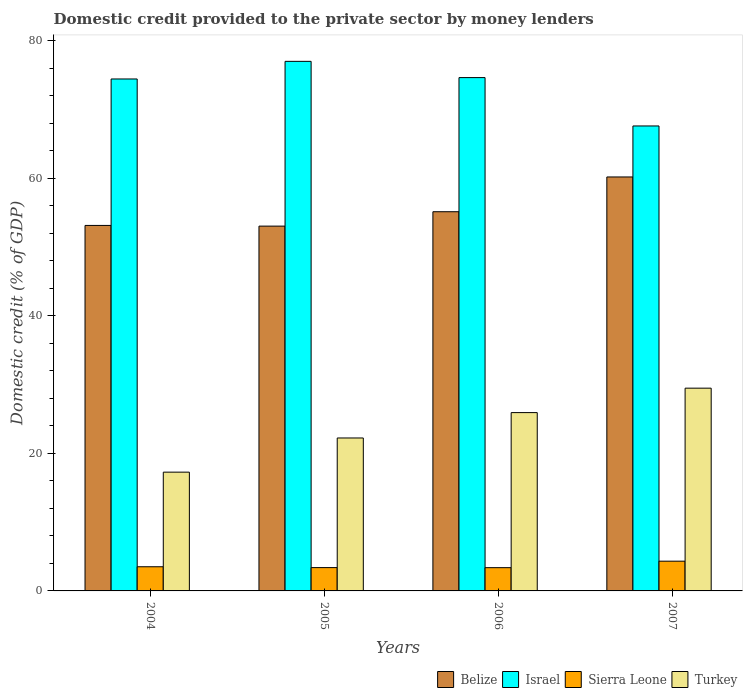How many different coloured bars are there?
Give a very brief answer. 4. Are the number of bars per tick equal to the number of legend labels?
Ensure brevity in your answer.  Yes. Are the number of bars on each tick of the X-axis equal?
Provide a succinct answer. Yes. How many bars are there on the 1st tick from the right?
Offer a very short reply. 4. What is the label of the 4th group of bars from the left?
Your response must be concise. 2007. What is the domestic credit provided to the private sector by money lenders in Belize in 2006?
Offer a terse response. 55.16. Across all years, what is the maximum domestic credit provided to the private sector by money lenders in Turkey?
Provide a succinct answer. 29.5. Across all years, what is the minimum domestic credit provided to the private sector by money lenders in Belize?
Offer a very short reply. 53.07. In which year was the domestic credit provided to the private sector by money lenders in Belize maximum?
Your answer should be very brief. 2007. In which year was the domestic credit provided to the private sector by money lenders in Israel minimum?
Provide a succinct answer. 2007. What is the total domestic credit provided to the private sector by money lenders in Belize in the graph?
Ensure brevity in your answer.  221.62. What is the difference between the domestic credit provided to the private sector by money lenders in Sierra Leone in 2005 and that in 2006?
Provide a succinct answer. 0.01. What is the difference between the domestic credit provided to the private sector by money lenders in Turkey in 2007 and the domestic credit provided to the private sector by money lenders in Israel in 2006?
Provide a short and direct response. -45.18. What is the average domestic credit provided to the private sector by money lenders in Belize per year?
Your response must be concise. 55.41. In the year 2007, what is the difference between the domestic credit provided to the private sector by money lenders in Sierra Leone and domestic credit provided to the private sector by money lenders in Turkey?
Ensure brevity in your answer.  -25.17. What is the ratio of the domestic credit provided to the private sector by money lenders in Turkey in 2004 to that in 2005?
Provide a succinct answer. 0.78. Is the domestic credit provided to the private sector by money lenders in Turkey in 2004 less than that in 2007?
Your answer should be very brief. Yes. What is the difference between the highest and the second highest domestic credit provided to the private sector by money lenders in Belize?
Your answer should be compact. 5.06. What is the difference between the highest and the lowest domestic credit provided to the private sector by money lenders in Sierra Leone?
Ensure brevity in your answer.  0.94. Is the sum of the domestic credit provided to the private sector by money lenders in Turkey in 2005 and 2006 greater than the maximum domestic credit provided to the private sector by money lenders in Sierra Leone across all years?
Offer a terse response. Yes. What does the 3rd bar from the left in 2007 represents?
Offer a very short reply. Sierra Leone. What does the 1st bar from the right in 2004 represents?
Make the answer very short. Turkey. How many bars are there?
Provide a short and direct response. 16. Are all the bars in the graph horizontal?
Your answer should be compact. No. How many years are there in the graph?
Keep it short and to the point. 4. What is the difference between two consecutive major ticks on the Y-axis?
Keep it short and to the point. 20. How many legend labels are there?
Ensure brevity in your answer.  4. How are the legend labels stacked?
Your answer should be very brief. Horizontal. What is the title of the graph?
Give a very brief answer. Domestic credit provided to the private sector by money lenders. Does "Greece" appear as one of the legend labels in the graph?
Provide a short and direct response. No. What is the label or title of the Y-axis?
Offer a very short reply. Domestic credit (% of GDP). What is the Domestic credit (% of GDP) in Belize in 2004?
Make the answer very short. 53.17. What is the Domestic credit (% of GDP) in Israel in 2004?
Your response must be concise. 74.47. What is the Domestic credit (% of GDP) of Sierra Leone in 2004?
Provide a succinct answer. 3.52. What is the Domestic credit (% of GDP) of Turkey in 2004?
Provide a short and direct response. 17.28. What is the Domestic credit (% of GDP) in Belize in 2005?
Keep it short and to the point. 53.07. What is the Domestic credit (% of GDP) in Israel in 2005?
Your answer should be compact. 77.04. What is the Domestic credit (% of GDP) in Sierra Leone in 2005?
Offer a terse response. 3.39. What is the Domestic credit (% of GDP) of Turkey in 2005?
Your answer should be very brief. 22.25. What is the Domestic credit (% of GDP) of Belize in 2006?
Your answer should be very brief. 55.16. What is the Domestic credit (% of GDP) in Israel in 2006?
Give a very brief answer. 74.67. What is the Domestic credit (% of GDP) of Sierra Leone in 2006?
Your answer should be compact. 3.38. What is the Domestic credit (% of GDP) in Turkey in 2006?
Offer a very short reply. 25.94. What is the Domestic credit (% of GDP) of Belize in 2007?
Provide a short and direct response. 60.22. What is the Domestic credit (% of GDP) in Israel in 2007?
Your answer should be very brief. 67.64. What is the Domestic credit (% of GDP) of Sierra Leone in 2007?
Make the answer very short. 4.33. What is the Domestic credit (% of GDP) of Turkey in 2007?
Give a very brief answer. 29.5. Across all years, what is the maximum Domestic credit (% of GDP) of Belize?
Your response must be concise. 60.22. Across all years, what is the maximum Domestic credit (% of GDP) in Israel?
Keep it short and to the point. 77.04. Across all years, what is the maximum Domestic credit (% of GDP) in Sierra Leone?
Give a very brief answer. 4.33. Across all years, what is the maximum Domestic credit (% of GDP) of Turkey?
Your answer should be compact. 29.5. Across all years, what is the minimum Domestic credit (% of GDP) of Belize?
Provide a short and direct response. 53.07. Across all years, what is the minimum Domestic credit (% of GDP) in Israel?
Provide a short and direct response. 67.64. Across all years, what is the minimum Domestic credit (% of GDP) of Sierra Leone?
Ensure brevity in your answer.  3.38. Across all years, what is the minimum Domestic credit (% of GDP) in Turkey?
Keep it short and to the point. 17.28. What is the total Domestic credit (% of GDP) of Belize in the graph?
Offer a very short reply. 221.62. What is the total Domestic credit (% of GDP) of Israel in the graph?
Your answer should be compact. 293.83. What is the total Domestic credit (% of GDP) in Sierra Leone in the graph?
Ensure brevity in your answer.  14.62. What is the total Domestic credit (% of GDP) of Turkey in the graph?
Provide a succinct answer. 94.97. What is the difference between the Domestic credit (% of GDP) of Belize in 2004 and that in 2005?
Offer a very short reply. 0.1. What is the difference between the Domestic credit (% of GDP) in Israel in 2004 and that in 2005?
Make the answer very short. -2.56. What is the difference between the Domestic credit (% of GDP) of Sierra Leone in 2004 and that in 2005?
Ensure brevity in your answer.  0.12. What is the difference between the Domestic credit (% of GDP) in Turkey in 2004 and that in 2005?
Your answer should be compact. -4.97. What is the difference between the Domestic credit (% of GDP) of Belize in 2004 and that in 2006?
Keep it short and to the point. -1.99. What is the difference between the Domestic credit (% of GDP) of Sierra Leone in 2004 and that in 2006?
Your answer should be compact. 0.13. What is the difference between the Domestic credit (% of GDP) of Turkey in 2004 and that in 2006?
Your answer should be compact. -8.66. What is the difference between the Domestic credit (% of GDP) of Belize in 2004 and that in 2007?
Ensure brevity in your answer.  -7.05. What is the difference between the Domestic credit (% of GDP) in Israel in 2004 and that in 2007?
Your answer should be compact. 6.84. What is the difference between the Domestic credit (% of GDP) of Sierra Leone in 2004 and that in 2007?
Give a very brief answer. -0.81. What is the difference between the Domestic credit (% of GDP) in Turkey in 2004 and that in 2007?
Make the answer very short. -12.22. What is the difference between the Domestic credit (% of GDP) of Belize in 2005 and that in 2006?
Provide a succinct answer. -2.09. What is the difference between the Domestic credit (% of GDP) in Israel in 2005 and that in 2006?
Offer a terse response. 2.36. What is the difference between the Domestic credit (% of GDP) of Sierra Leone in 2005 and that in 2006?
Your answer should be compact. 0.01. What is the difference between the Domestic credit (% of GDP) in Turkey in 2005 and that in 2006?
Give a very brief answer. -3.69. What is the difference between the Domestic credit (% of GDP) in Belize in 2005 and that in 2007?
Your response must be concise. -7.15. What is the difference between the Domestic credit (% of GDP) in Israel in 2005 and that in 2007?
Keep it short and to the point. 9.4. What is the difference between the Domestic credit (% of GDP) of Sierra Leone in 2005 and that in 2007?
Your answer should be very brief. -0.93. What is the difference between the Domestic credit (% of GDP) of Turkey in 2005 and that in 2007?
Keep it short and to the point. -7.25. What is the difference between the Domestic credit (% of GDP) in Belize in 2006 and that in 2007?
Offer a very short reply. -5.06. What is the difference between the Domestic credit (% of GDP) in Israel in 2006 and that in 2007?
Offer a very short reply. 7.04. What is the difference between the Domestic credit (% of GDP) of Sierra Leone in 2006 and that in 2007?
Provide a short and direct response. -0.94. What is the difference between the Domestic credit (% of GDP) in Turkey in 2006 and that in 2007?
Provide a succinct answer. -3.55. What is the difference between the Domestic credit (% of GDP) of Belize in 2004 and the Domestic credit (% of GDP) of Israel in 2005?
Provide a short and direct response. -23.87. What is the difference between the Domestic credit (% of GDP) of Belize in 2004 and the Domestic credit (% of GDP) of Sierra Leone in 2005?
Your answer should be very brief. 49.78. What is the difference between the Domestic credit (% of GDP) of Belize in 2004 and the Domestic credit (% of GDP) of Turkey in 2005?
Give a very brief answer. 30.92. What is the difference between the Domestic credit (% of GDP) of Israel in 2004 and the Domestic credit (% of GDP) of Sierra Leone in 2005?
Provide a succinct answer. 71.08. What is the difference between the Domestic credit (% of GDP) of Israel in 2004 and the Domestic credit (% of GDP) of Turkey in 2005?
Ensure brevity in your answer.  52.23. What is the difference between the Domestic credit (% of GDP) of Sierra Leone in 2004 and the Domestic credit (% of GDP) of Turkey in 2005?
Your response must be concise. -18.73. What is the difference between the Domestic credit (% of GDP) in Belize in 2004 and the Domestic credit (% of GDP) in Israel in 2006?
Provide a succinct answer. -21.5. What is the difference between the Domestic credit (% of GDP) in Belize in 2004 and the Domestic credit (% of GDP) in Sierra Leone in 2006?
Your answer should be very brief. 49.79. What is the difference between the Domestic credit (% of GDP) in Belize in 2004 and the Domestic credit (% of GDP) in Turkey in 2006?
Provide a short and direct response. 27.23. What is the difference between the Domestic credit (% of GDP) in Israel in 2004 and the Domestic credit (% of GDP) in Sierra Leone in 2006?
Offer a very short reply. 71.09. What is the difference between the Domestic credit (% of GDP) in Israel in 2004 and the Domestic credit (% of GDP) in Turkey in 2006?
Your answer should be very brief. 48.53. What is the difference between the Domestic credit (% of GDP) in Sierra Leone in 2004 and the Domestic credit (% of GDP) in Turkey in 2006?
Offer a very short reply. -22.43. What is the difference between the Domestic credit (% of GDP) of Belize in 2004 and the Domestic credit (% of GDP) of Israel in 2007?
Provide a short and direct response. -14.47. What is the difference between the Domestic credit (% of GDP) of Belize in 2004 and the Domestic credit (% of GDP) of Sierra Leone in 2007?
Offer a terse response. 48.84. What is the difference between the Domestic credit (% of GDP) in Belize in 2004 and the Domestic credit (% of GDP) in Turkey in 2007?
Your answer should be very brief. 23.67. What is the difference between the Domestic credit (% of GDP) of Israel in 2004 and the Domestic credit (% of GDP) of Sierra Leone in 2007?
Your response must be concise. 70.15. What is the difference between the Domestic credit (% of GDP) of Israel in 2004 and the Domestic credit (% of GDP) of Turkey in 2007?
Provide a short and direct response. 44.98. What is the difference between the Domestic credit (% of GDP) in Sierra Leone in 2004 and the Domestic credit (% of GDP) in Turkey in 2007?
Give a very brief answer. -25.98. What is the difference between the Domestic credit (% of GDP) in Belize in 2005 and the Domestic credit (% of GDP) in Israel in 2006?
Make the answer very short. -21.61. What is the difference between the Domestic credit (% of GDP) of Belize in 2005 and the Domestic credit (% of GDP) of Sierra Leone in 2006?
Offer a very short reply. 49.68. What is the difference between the Domestic credit (% of GDP) of Belize in 2005 and the Domestic credit (% of GDP) of Turkey in 2006?
Offer a terse response. 27.13. What is the difference between the Domestic credit (% of GDP) of Israel in 2005 and the Domestic credit (% of GDP) of Sierra Leone in 2006?
Make the answer very short. 73.65. What is the difference between the Domestic credit (% of GDP) in Israel in 2005 and the Domestic credit (% of GDP) in Turkey in 2006?
Keep it short and to the point. 51.1. What is the difference between the Domestic credit (% of GDP) of Sierra Leone in 2005 and the Domestic credit (% of GDP) of Turkey in 2006?
Offer a very short reply. -22.55. What is the difference between the Domestic credit (% of GDP) in Belize in 2005 and the Domestic credit (% of GDP) in Israel in 2007?
Offer a terse response. -14.57. What is the difference between the Domestic credit (% of GDP) in Belize in 2005 and the Domestic credit (% of GDP) in Sierra Leone in 2007?
Ensure brevity in your answer.  48.74. What is the difference between the Domestic credit (% of GDP) in Belize in 2005 and the Domestic credit (% of GDP) in Turkey in 2007?
Keep it short and to the point. 23.57. What is the difference between the Domestic credit (% of GDP) in Israel in 2005 and the Domestic credit (% of GDP) in Sierra Leone in 2007?
Make the answer very short. 72.71. What is the difference between the Domestic credit (% of GDP) in Israel in 2005 and the Domestic credit (% of GDP) in Turkey in 2007?
Ensure brevity in your answer.  47.54. What is the difference between the Domestic credit (% of GDP) of Sierra Leone in 2005 and the Domestic credit (% of GDP) of Turkey in 2007?
Ensure brevity in your answer.  -26.1. What is the difference between the Domestic credit (% of GDP) in Belize in 2006 and the Domestic credit (% of GDP) in Israel in 2007?
Provide a short and direct response. -12.48. What is the difference between the Domestic credit (% of GDP) in Belize in 2006 and the Domestic credit (% of GDP) in Sierra Leone in 2007?
Make the answer very short. 50.83. What is the difference between the Domestic credit (% of GDP) of Belize in 2006 and the Domestic credit (% of GDP) of Turkey in 2007?
Make the answer very short. 25.67. What is the difference between the Domestic credit (% of GDP) in Israel in 2006 and the Domestic credit (% of GDP) in Sierra Leone in 2007?
Provide a short and direct response. 70.35. What is the difference between the Domestic credit (% of GDP) of Israel in 2006 and the Domestic credit (% of GDP) of Turkey in 2007?
Your answer should be compact. 45.18. What is the difference between the Domestic credit (% of GDP) of Sierra Leone in 2006 and the Domestic credit (% of GDP) of Turkey in 2007?
Provide a succinct answer. -26.11. What is the average Domestic credit (% of GDP) of Belize per year?
Give a very brief answer. 55.41. What is the average Domestic credit (% of GDP) in Israel per year?
Provide a short and direct response. 73.46. What is the average Domestic credit (% of GDP) in Sierra Leone per year?
Keep it short and to the point. 3.65. What is the average Domestic credit (% of GDP) of Turkey per year?
Provide a succinct answer. 23.74. In the year 2004, what is the difference between the Domestic credit (% of GDP) of Belize and Domestic credit (% of GDP) of Israel?
Ensure brevity in your answer.  -21.3. In the year 2004, what is the difference between the Domestic credit (% of GDP) in Belize and Domestic credit (% of GDP) in Sierra Leone?
Your answer should be compact. 49.65. In the year 2004, what is the difference between the Domestic credit (% of GDP) of Belize and Domestic credit (% of GDP) of Turkey?
Offer a terse response. 35.89. In the year 2004, what is the difference between the Domestic credit (% of GDP) of Israel and Domestic credit (% of GDP) of Sierra Leone?
Ensure brevity in your answer.  70.96. In the year 2004, what is the difference between the Domestic credit (% of GDP) in Israel and Domestic credit (% of GDP) in Turkey?
Provide a succinct answer. 57.2. In the year 2004, what is the difference between the Domestic credit (% of GDP) of Sierra Leone and Domestic credit (% of GDP) of Turkey?
Keep it short and to the point. -13.76. In the year 2005, what is the difference between the Domestic credit (% of GDP) of Belize and Domestic credit (% of GDP) of Israel?
Make the answer very short. -23.97. In the year 2005, what is the difference between the Domestic credit (% of GDP) of Belize and Domestic credit (% of GDP) of Sierra Leone?
Your response must be concise. 49.68. In the year 2005, what is the difference between the Domestic credit (% of GDP) of Belize and Domestic credit (% of GDP) of Turkey?
Give a very brief answer. 30.82. In the year 2005, what is the difference between the Domestic credit (% of GDP) of Israel and Domestic credit (% of GDP) of Sierra Leone?
Ensure brevity in your answer.  73.65. In the year 2005, what is the difference between the Domestic credit (% of GDP) of Israel and Domestic credit (% of GDP) of Turkey?
Offer a very short reply. 54.79. In the year 2005, what is the difference between the Domestic credit (% of GDP) in Sierra Leone and Domestic credit (% of GDP) in Turkey?
Your response must be concise. -18.86. In the year 2006, what is the difference between the Domestic credit (% of GDP) of Belize and Domestic credit (% of GDP) of Israel?
Provide a short and direct response. -19.51. In the year 2006, what is the difference between the Domestic credit (% of GDP) in Belize and Domestic credit (% of GDP) in Sierra Leone?
Provide a short and direct response. 51.78. In the year 2006, what is the difference between the Domestic credit (% of GDP) in Belize and Domestic credit (% of GDP) in Turkey?
Make the answer very short. 29.22. In the year 2006, what is the difference between the Domestic credit (% of GDP) in Israel and Domestic credit (% of GDP) in Sierra Leone?
Make the answer very short. 71.29. In the year 2006, what is the difference between the Domestic credit (% of GDP) in Israel and Domestic credit (% of GDP) in Turkey?
Give a very brief answer. 48.73. In the year 2006, what is the difference between the Domestic credit (% of GDP) in Sierra Leone and Domestic credit (% of GDP) in Turkey?
Provide a succinct answer. -22.56. In the year 2007, what is the difference between the Domestic credit (% of GDP) of Belize and Domestic credit (% of GDP) of Israel?
Provide a short and direct response. -7.42. In the year 2007, what is the difference between the Domestic credit (% of GDP) in Belize and Domestic credit (% of GDP) in Sierra Leone?
Provide a succinct answer. 55.89. In the year 2007, what is the difference between the Domestic credit (% of GDP) in Belize and Domestic credit (% of GDP) in Turkey?
Your answer should be compact. 30.72. In the year 2007, what is the difference between the Domestic credit (% of GDP) in Israel and Domestic credit (% of GDP) in Sierra Leone?
Provide a succinct answer. 63.31. In the year 2007, what is the difference between the Domestic credit (% of GDP) of Israel and Domestic credit (% of GDP) of Turkey?
Offer a terse response. 38.14. In the year 2007, what is the difference between the Domestic credit (% of GDP) in Sierra Leone and Domestic credit (% of GDP) in Turkey?
Keep it short and to the point. -25.17. What is the ratio of the Domestic credit (% of GDP) in Israel in 2004 to that in 2005?
Make the answer very short. 0.97. What is the ratio of the Domestic credit (% of GDP) of Sierra Leone in 2004 to that in 2005?
Ensure brevity in your answer.  1.04. What is the ratio of the Domestic credit (% of GDP) in Turkey in 2004 to that in 2005?
Offer a terse response. 0.78. What is the ratio of the Domestic credit (% of GDP) of Belize in 2004 to that in 2006?
Your answer should be very brief. 0.96. What is the ratio of the Domestic credit (% of GDP) of Israel in 2004 to that in 2006?
Your response must be concise. 1. What is the ratio of the Domestic credit (% of GDP) of Sierra Leone in 2004 to that in 2006?
Provide a succinct answer. 1.04. What is the ratio of the Domestic credit (% of GDP) in Turkey in 2004 to that in 2006?
Your answer should be compact. 0.67. What is the ratio of the Domestic credit (% of GDP) of Belize in 2004 to that in 2007?
Provide a succinct answer. 0.88. What is the ratio of the Domestic credit (% of GDP) in Israel in 2004 to that in 2007?
Offer a very short reply. 1.1. What is the ratio of the Domestic credit (% of GDP) of Sierra Leone in 2004 to that in 2007?
Your answer should be very brief. 0.81. What is the ratio of the Domestic credit (% of GDP) in Turkey in 2004 to that in 2007?
Your answer should be very brief. 0.59. What is the ratio of the Domestic credit (% of GDP) of Israel in 2005 to that in 2006?
Provide a succinct answer. 1.03. What is the ratio of the Domestic credit (% of GDP) in Turkey in 2005 to that in 2006?
Provide a succinct answer. 0.86. What is the ratio of the Domestic credit (% of GDP) in Belize in 2005 to that in 2007?
Give a very brief answer. 0.88. What is the ratio of the Domestic credit (% of GDP) in Israel in 2005 to that in 2007?
Your answer should be very brief. 1.14. What is the ratio of the Domestic credit (% of GDP) in Sierra Leone in 2005 to that in 2007?
Your response must be concise. 0.78. What is the ratio of the Domestic credit (% of GDP) in Turkey in 2005 to that in 2007?
Keep it short and to the point. 0.75. What is the ratio of the Domestic credit (% of GDP) of Belize in 2006 to that in 2007?
Ensure brevity in your answer.  0.92. What is the ratio of the Domestic credit (% of GDP) of Israel in 2006 to that in 2007?
Give a very brief answer. 1.1. What is the ratio of the Domestic credit (% of GDP) in Sierra Leone in 2006 to that in 2007?
Offer a very short reply. 0.78. What is the ratio of the Domestic credit (% of GDP) of Turkey in 2006 to that in 2007?
Your answer should be compact. 0.88. What is the difference between the highest and the second highest Domestic credit (% of GDP) in Belize?
Your answer should be compact. 5.06. What is the difference between the highest and the second highest Domestic credit (% of GDP) in Israel?
Provide a short and direct response. 2.36. What is the difference between the highest and the second highest Domestic credit (% of GDP) in Sierra Leone?
Provide a short and direct response. 0.81. What is the difference between the highest and the second highest Domestic credit (% of GDP) in Turkey?
Provide a succinct answer. 3.55. What is the difference between the highest and the lowest Domestic credit (% of GDP) of Belize?
Offer a terse response. 7.15. What is the difference between the highest and the lowest Domestic credit (% of GDP) of Israel?
Provide a succinct answer. 9.4. What is the difference between the highest and the lowest Domestic credit (% of GDP) of Sierra Leone?
Make the answer very short. 0.94. What is the difference between the highest and the lowest Domestic credit (% of GDP) in Turkey?
Ensure brevity in your answer.  12.22. 